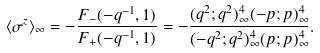Convert formula to latex. <formula><loc_0><loc_0><loc_500><loc_500>\langle \sigma ^ { z } \rangle _ { \infty } = - \frac { F _ { - } ( - q ^ { - 1 } , 1 ) } { F _ { + } ( - q ^ { - 1 } , 1 ) } = - \frac { ( q ^ { 2 } ; q ^ { 2 } ) _ { \infty } ^ { 4 } ( - p ; p ) _ { \infty } ^ { 4 } } { ( - q ^ { 2 } ; q ^ { 2 } ) _ { \infty } ^ { 4 } ( p ; p ) _ { \infty } ^ { 4 } } .</formula> 